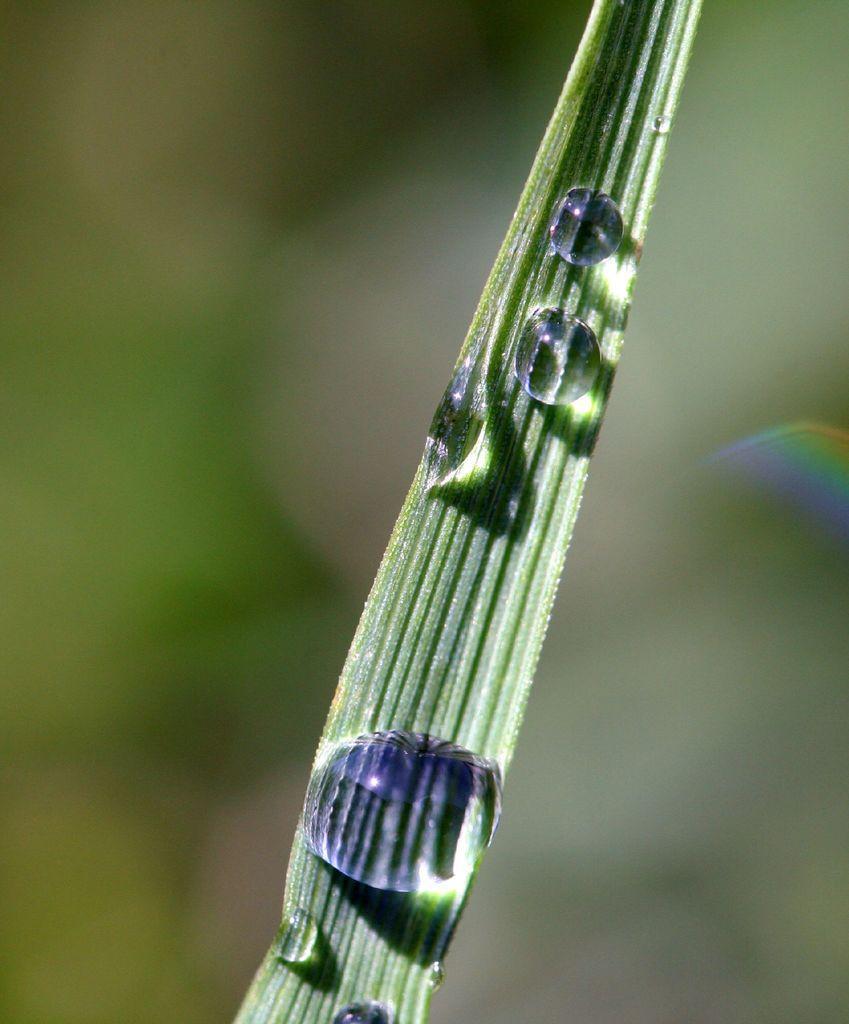Describe this image in one or two sentences. In this image we can see some droplets of water on a leaf. 